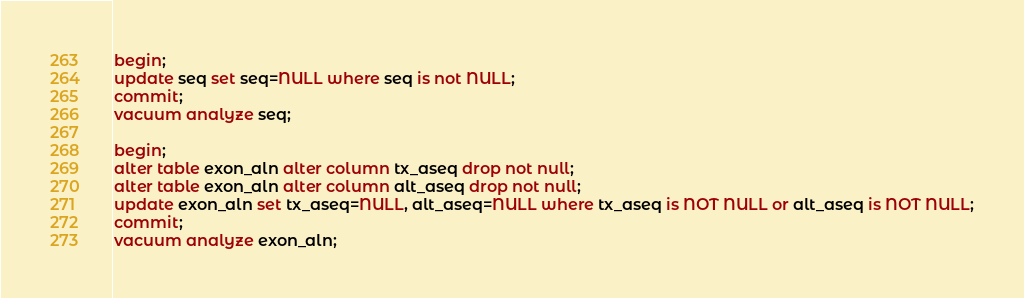Convert code to text. <code><loc_0><loc_0><loc_500><loc_500><_SQL_>begin;
update seq set seq=NULL where seq is not NULL;
commit;
vacuum analyze seq;

begin;
alter table exon_aln alter column tx_aseq drop not null;
alter table exon_aln alter column alt_aseq drop not null;
update exon_aln set tx_aseq=NULL, alt_aseq=NULL where tx_aseq is NOT NULL or alt_aseq is NOT NULL;
commit;
vacuum analyze exon_aln;
</code> 